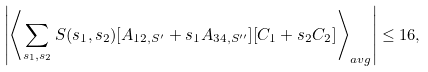Convert formula to latex. <formula><loc_0><loc_0><loc_500><loc_500>\left | \left \langle \sum _ { s _ { 1 } , s _ { 2 } } S ( s _ { 1 } , s _ { 2 } ) [ A _ { 1 2 , S ^ { \prime } } + s _ { 1 } A _ { 3 4 , S ^ { \prime \prime } } ] [ C _ { 1 } + s _ { 2 } C _ { 2 } ] \right \rangle _ { a v g } \right | \leq 1 6 ,</formula> 